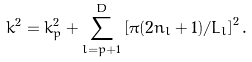<formula> <loc_0><loc_0><loc_500><loc_500>k ^ { 2 } = k _ { p } ^ { 2 } + \sum _ { l = p + 1 } ^ { D } \left [ \pi ( 2 n _ { l } + 1 ) / L _ { l } \right ] ^ { 2 } .</formula> 